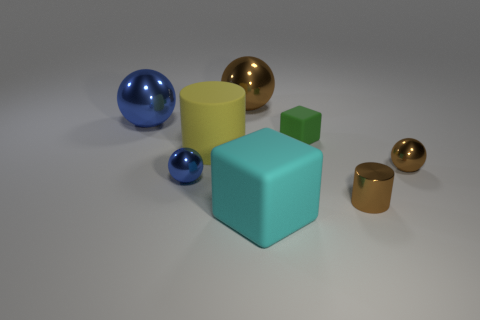Subtract all gray cubes. How many brown balls are left? 2 Add 1 shiny balls. How many objects exist? 9 Subtract all small blue metal spheres. How many spheres are left? 3 Subtract all cubes. How many objects are left? 6 Subtract all purple balls. Subtract all gray blocks. How many balls are left? 4 Subtract all green shiny things. Subtract all shiny cylinders. How many objects are left? 7 Add 1 tiny metal things. How many tiny metal things are left? 4 Add 7 small gray matte cylinders. How many small gray matte cylinders exist? 7 Subtract 0 yellow blocks. How many objects are left? 8 